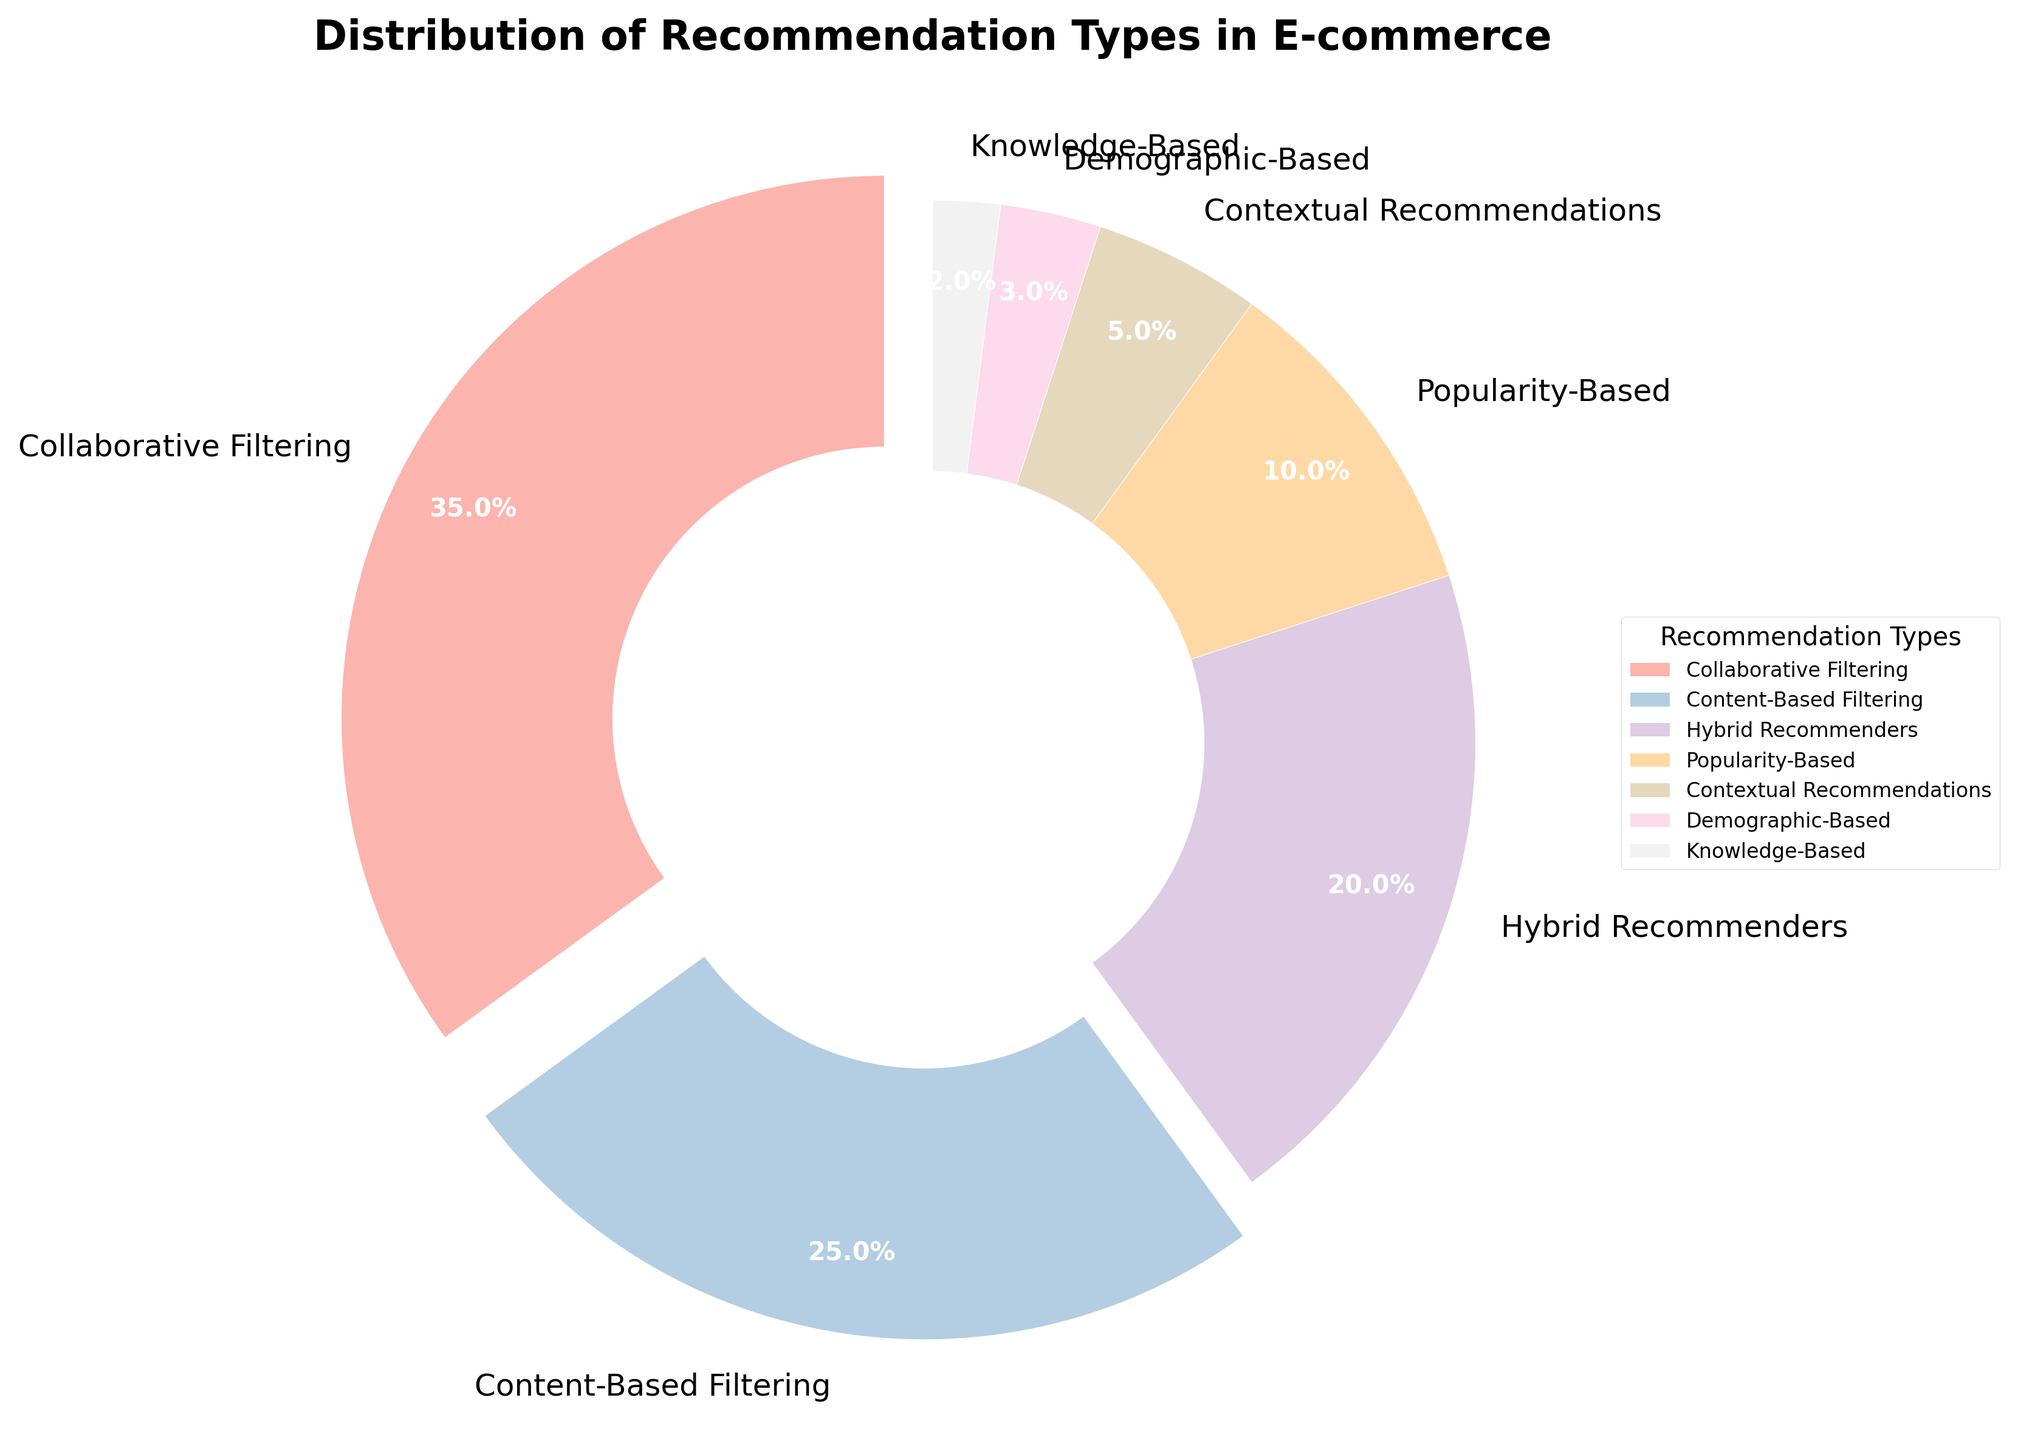What percentage of the recommendation types use filtering methods (Collaborative Filtering and Content-Based Filtering)? Add the percentages of Collaborative Filtering (35%) and Content-Based Filtering (25%): 35 + 25 = 60
Answer: 60% Which recommendation type has the smallest percentage? By examining the pie chart, the smallest wedge represents Knowledge-Based recommendations at 2%
Answer: Knowledge-Based recommendations What is the difference in percentage between Hybrid Recommenders and Contextual Recommendations? The percentage for Hybrid Recommenders is 20%, and for Contextual Recommendations, it is 5%. Subtract 5 from 20: 20 - 5 = 15
Answer: 15% Which recommendation types are highlighted (exploded) in the pie chart? The exploded wedges represent Collaborative Filtering (35%) and Content-Based Filtering (25%), as they are the largest slices in the chart
Answer: Collaborative Filtering and Content-Based Filtering How do the percentages of the Popularity-Based and Demographic-Based recommendation types compare? Popularity-Based recommendation is 10%, and Demographic-Based recommendation is 3%. 10 is greater than 3
Answer: Popularity-Based is greater What is the total percentage of recommendation types that use either Demographic-Based or Knowledge-Based methods? Add the percentages of Demographic-Based (3%) and Knowledge-Based (2%): 3 + 2 = 5
Answer: 5% Which category has the second highest percentage, and what is it? The second largest wedge after Collaborative Filtering (35%) is Content-Based Filtering at 25%
Answer: Content-Based Filtering at 25% If you combine the percentages of Demographic-Based, Knowledge-Based, and Contextual Recommendations, do they exceed that of Hybrid Recommenders? Add the percentages of Demographic-Based (3%), Knowledge-Based (2%), and Contextual Recommendations (5%): 3 + 2 + 5 = 10. Compare this with Hybrid Recommenders at 20%. 10 is not greater than 20
Answer: No Among the recommendation types with percentages less than 10%, which has the highest percentage, and what is it? Demographic-Based (3%) and Knowledge-Based (2%) are both less than 10%, with Contextual Recommendations being the closest at 5%
Answer: Contextual Recommendations at 5% What is the percentage difference between the highest and lowest recommendation type percentages? The highest percentage is Collaborative Filtering at 35% and the lowest is Knowledge-Based at 2%. Subtract 2 from 35: 35 - 2 = 33
Answer: 33% 